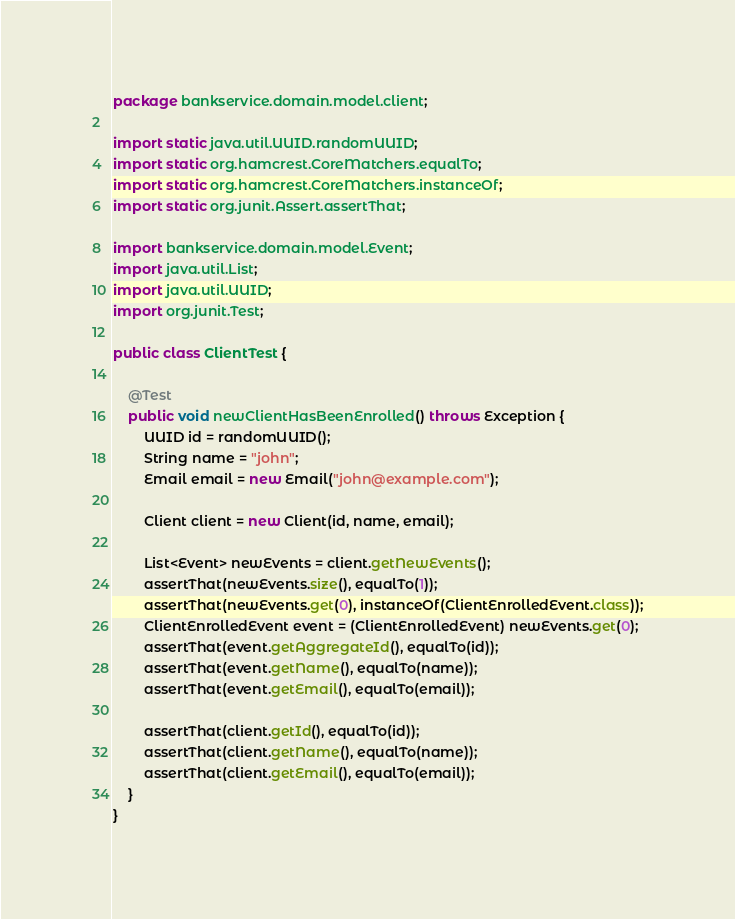<code> <loc_0><loc_0><loc_500><loc_500><_Java_>package bankservice.domain.model.client;

import static java.util.UUID.randomUUID;
import static org.hamcrest.CoreMatchers.equalTo;
import static org.hamcrest.CoreMatchers.instanceOf;
import static org.junit.Assert.assertThat;

import bankservice.domain.model.Event;
import java.util.List;
import java.util.UUID;
import org.junit.Test;

public class ClientTest {

    @Test
    public void newClientHasBeenEnrolled() throws Exception {
        UUID id = randomUUID();
        String name = "john";
        Email email = new Email("john@example.com");

        Client client = new Client(id, name, email);

        List<Event> newEvents = client.getNewEvents();
        assertThat(newEvents.size(), equalTo(1));
        assertThat(newEvents.get(0), instanceOf(ClientEnrolledEvent.class));
        ClientEnrolledEvent event = (ClientEnrolledEvent) newEvents.get(0);
        assertThat(event.getAggregateId(), equalTo(id));
        assertThat(event.getName(), equalTo(name));
        assertThat(event.getEmail(), equalTo(email));

        assertThat(client.getId(), equalTo(id));
        assertThat(client.getName(), equalTo(name));
        assertThat(client.getEmail(), equalTo(email));
    }
}
</code> 